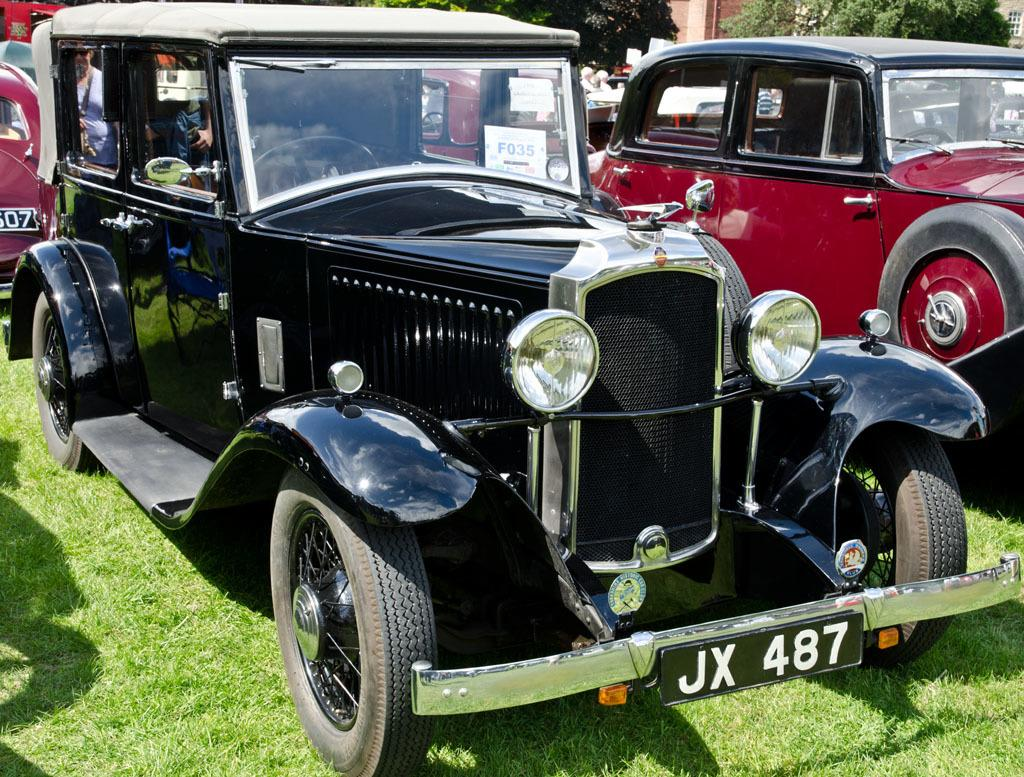What type of objects with number plates can be seen in the image? There are vehicles with number plates in the image. What is the ground surface like in the image? There is grass on the ground in the image. What can be seen in the background of the image? There are trees in the background of the image. What type of substance is flowing from the mountain in the image? There is no mountain or substance flowing in the image; it features vehicles with number plates, grass, and trees. 